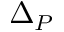Convert formula to latex. <formula><loc_0><loc_0><loc_500><loc_500>\Delta _ { P }</formula> 